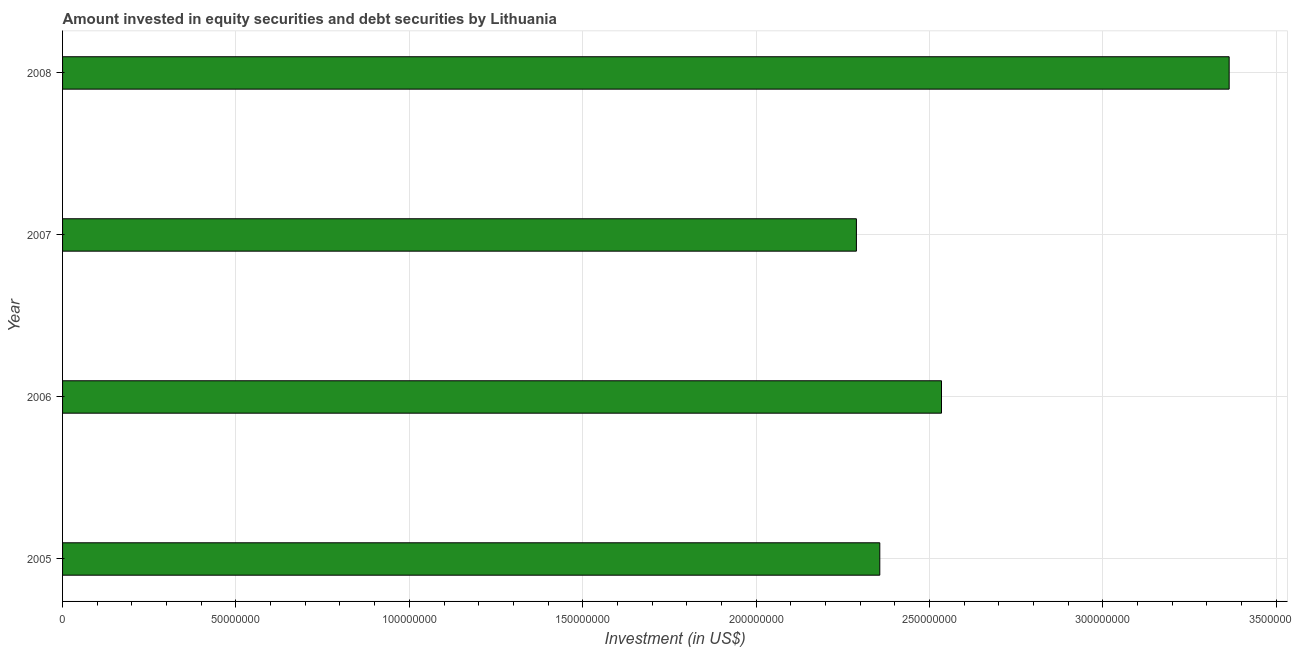What is the title of the graph?
Keep it short and to the point. Amount invested in equity securities and debt securities by Lithuania. What is the label or title of the X-axis?
Ensure brevity in your answer.  Investment (in US$). What is the label or title of the Y-axis?
Offer a terse response. Year. What is the portfolio investment in 2005?
Your response must be concise. 2.36e+08. Across all years, what is the maximum portfolio investment?
Provide a short and direct response. 3.36e+08. Across all years, what is the minimum portfolio investment?
Your answer should be very brief. 2.29e+08. In which year was the portfolio investment maximum?
Provide a short and direct response. 2008. What is the sum of the portfolio investment?
Provide a succinct answer. 1.05e+09. What is the difference between the portfolio investment in 2007 and 2008?
Ensure brevity in your answer.  -1.07e+08. What is the average portfolio investment per year?
Your answer should be very brief. 2.64e+08. What is the median portfolio investment?
Your answer should be very brief. 2.45e+08. Do a majority of the years between 2006 and 2007 (inclusive) have portfolio investment greater than 20000000 US$?
Your answer should be very brief. Yes. What is the ratio of the portfolio investment in 2005 to that in 2008?
Give a very brief answer. 0.7. Is the portfolio investment in 2006 less than that in 2008?
Make the answer very short. Yes. Is the difference between the portfolio investment in 2005 and 2008 greater than the difference between any two years?
Keep it short and to the point. No. What is the difference between the highest and the second highest portfolio investment?
Give a very brief answer. 8.30e+07. Is the sum of the portfolio investment in 2006 and 2007 greater than the maximum portfolio investment across all years?
Offer a terse response. Yes. What is the difference between the highest and the lowest portfolio investment?
Keep it short and to the point. 1.07e+08. How many years are there in the graph?
Provide a succinct answer. 4. What is the Investment (in US$) in 2005?
Your response must be concise. 2.36e+08. What is the Investment (in US$) of 2006?
Offer a terse response. 2.53e+08. What is the Investment (in US$) of 2007?
Provide a succinct answer. 2.29e+08. What is the Investment (in US$) of 2008?
Offer a terse response. 3.36e+08. What is the difference between the Investment (in US$) in 2005 and 2006?
Your answer should be very brief. -1.78e+07. What is the difference between the Investment (in US$) in 2005 and 2007?
Offer a very short reply. 6.75e+06. What is the difference between the Investment (in US$) in 2005 and 2008?
Make the answer very short. -1.01e+08. What is the difference between the Investment (in US$) in 2006 and 2007?
Your answer should be compact. 2.45e+07. What is the difference between the Investment (in US$) in 2006 and 2008?
Your answer should be compact. -8.30e+07. What is the difference between the Investment (in US$) in 2007 and 2008?
Provide a succinct answer. -1.07e+08. What is the ratio of the Investment (in US$) in 2005 to that in 2008?
Offer a terse response. 0.7. What is the ratio of the Investment (in US$) in 2006 to that in 2007?
Offer a terse response. 1.11. What is the ratio of the Investment (in US$) in 2006 to that in 2008?
Ensure brevity in your answer.  0.75. What is the ratio of the Investment (in US$) in 2007 to that in 2008?
Your response must be concise. 0.68. 